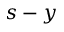Convert formula to latex. <formula><loc_0><loc_0><loc_500><loc_500>s - y</formula> 